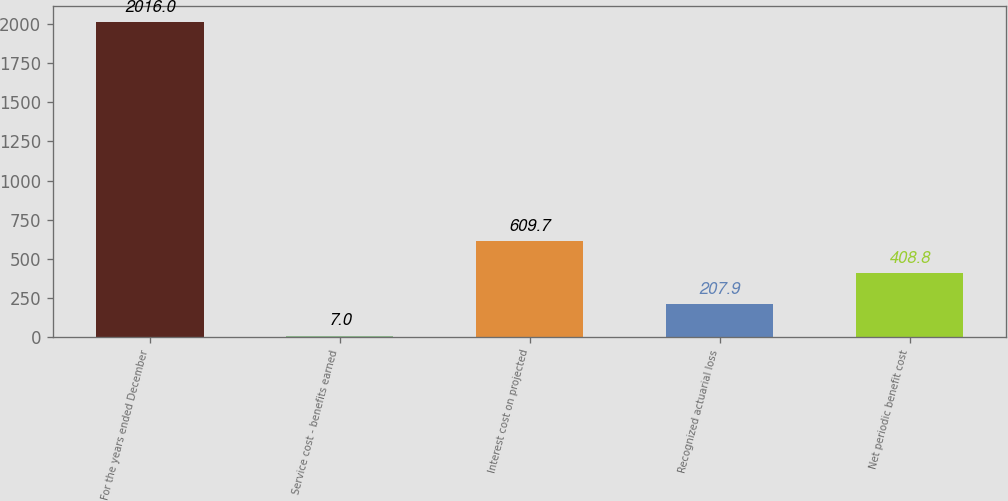<chart> <loc_0><loc_0><loc_500><loc_500><bar_chart><fcel>For the years ended December<fcel>Service cost - benefits earned<fcel>Interest cost on projected<fcel>Recognized actuarial loss<fcel>Net periodic benefit cost<nl><fcel>2016<fcel>7<fcel>609.7<fcel>207.9<fcel>408.8<nl></chart> 